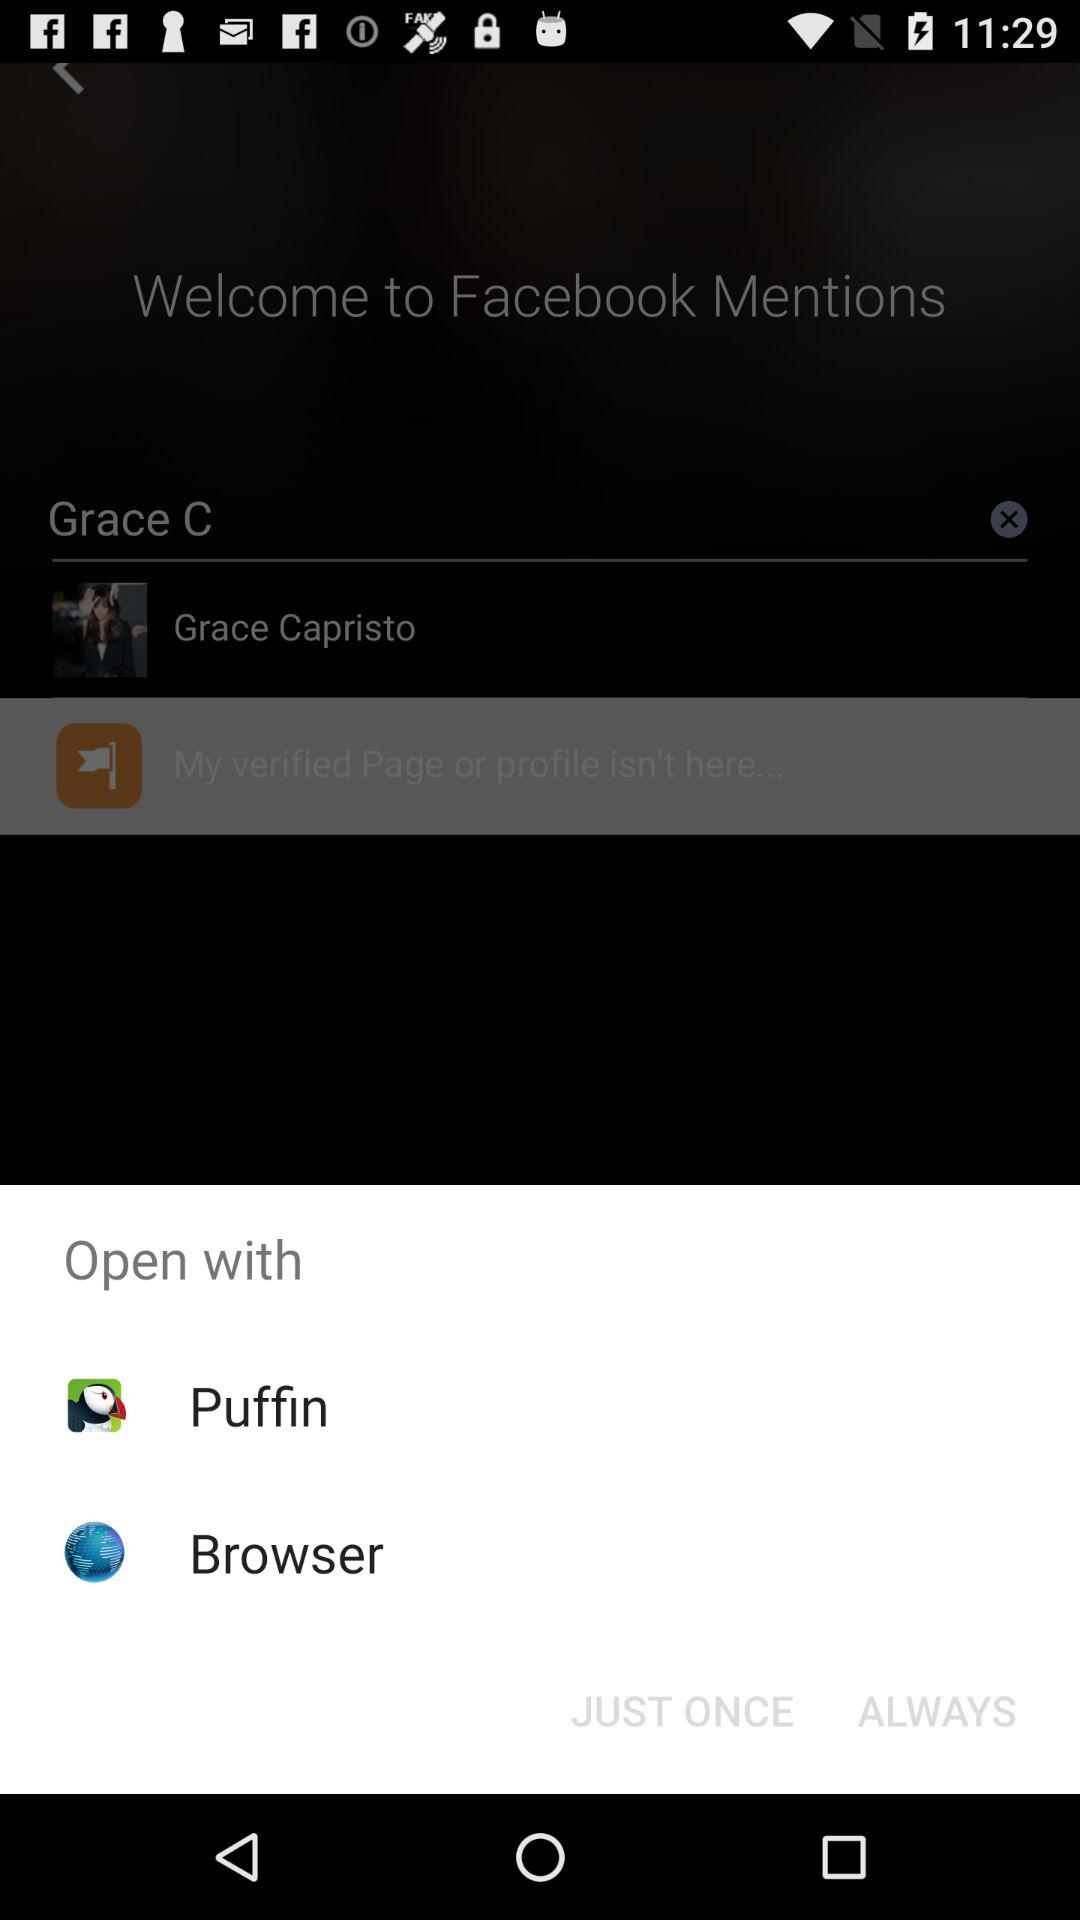Through which application can we open it? You can open it through "Puffin" and "Browser". 